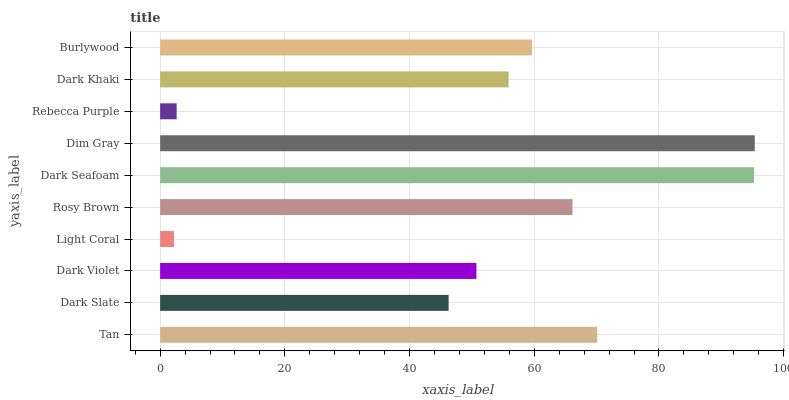Is Light Coral the minimum?
Answer yes or no. Yes. Is Dim Gray the maximum?
Answer yes or no. Yes. Is Dark Slate the minimum?
Answer yes or no. No. Is Dark Slate the maximum?
Answer yes or no. No. Is Tan greater than Dark Slate?
Answer yes or no. Yes. Is Dark Slate less than Tan?
Answer yes or no. Yes. Is Dark Slate greater than Tan?
Answer yes or no. No. Is Tan less than Dark Slate?
Answer yes or no. No. Is Burlywood the high median?
Answer yes or no. Yes. Is Dark Khaki the low median?
Answer yes or no. Yes. Is Dark Violet the high median?
Answer yes or no. No. Is Tan the low median?
Answer yes or no. No. 